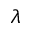Convert formula to latex. <formula><loc_0><loc_0><loc_500><loc_500>\lambda</formula> 